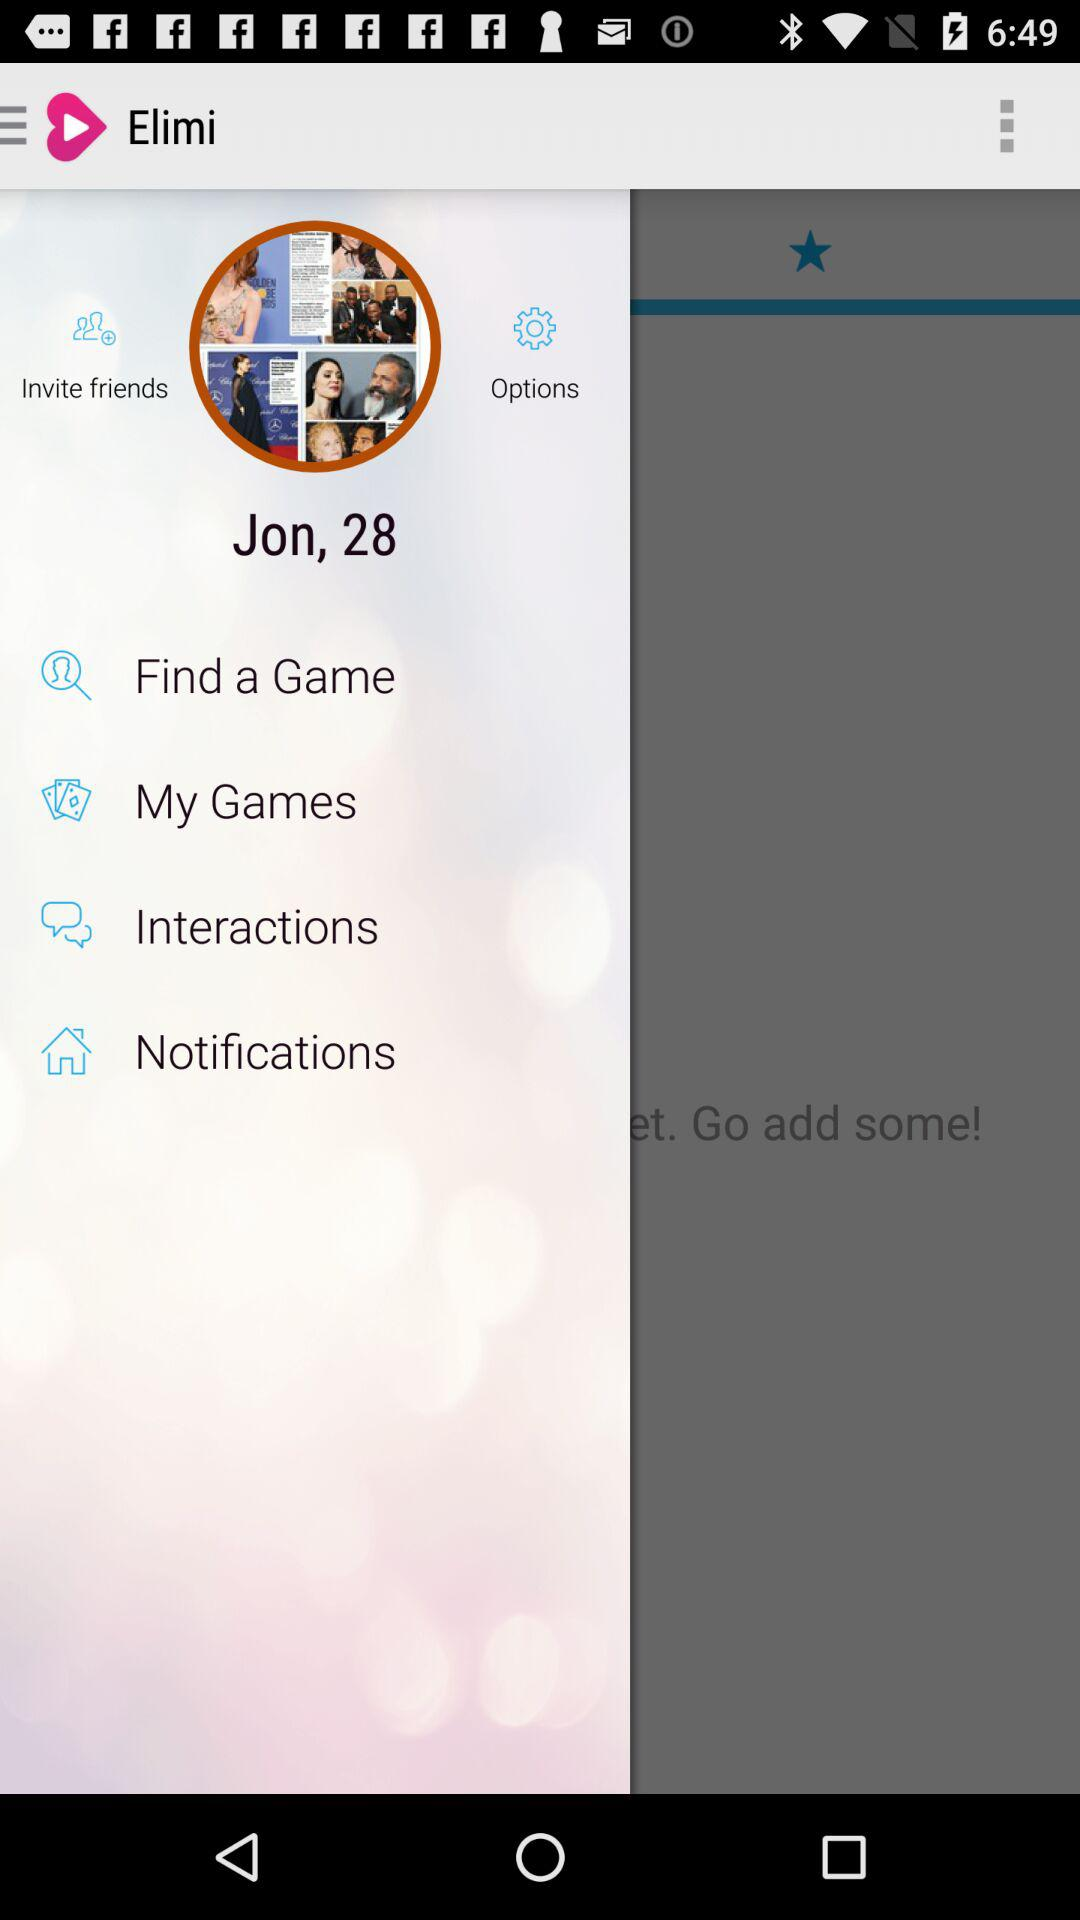What is the user name? The user name is "Jon". 